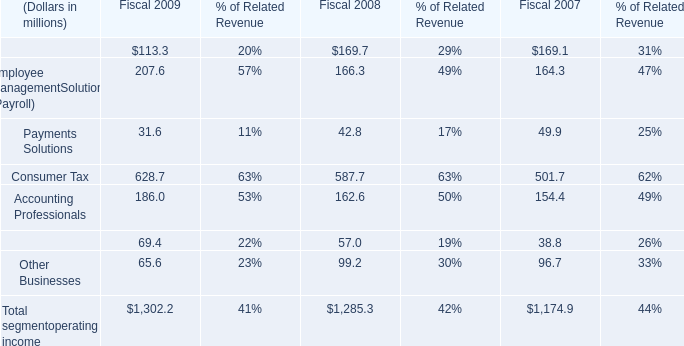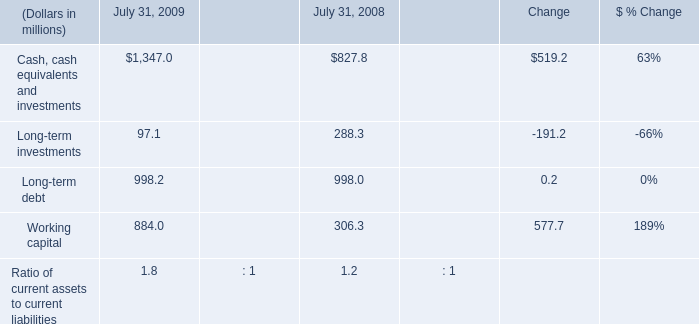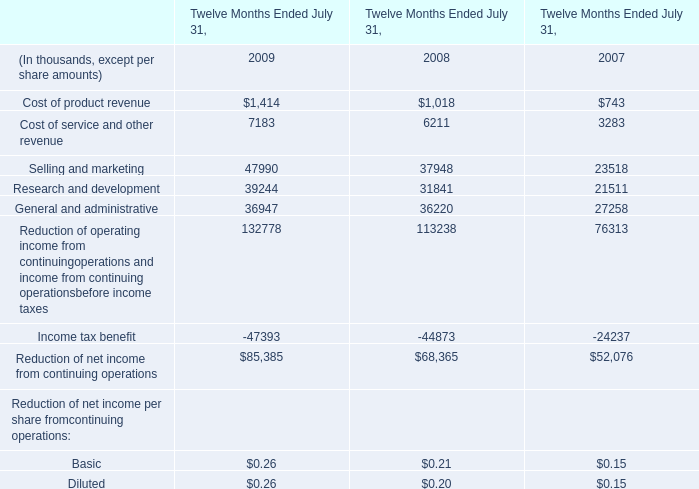What's the sum of Selling and marketing of Twelve Months Ended July 31, 2008, Cash, cash equivalents and investments of July 31, 2009, and Research and development of Twelve Months Ended July 31, 2009 ? 
Computations: ((37948.0 + 1347.0) + 39244.0)
Answer: 78539.0. 